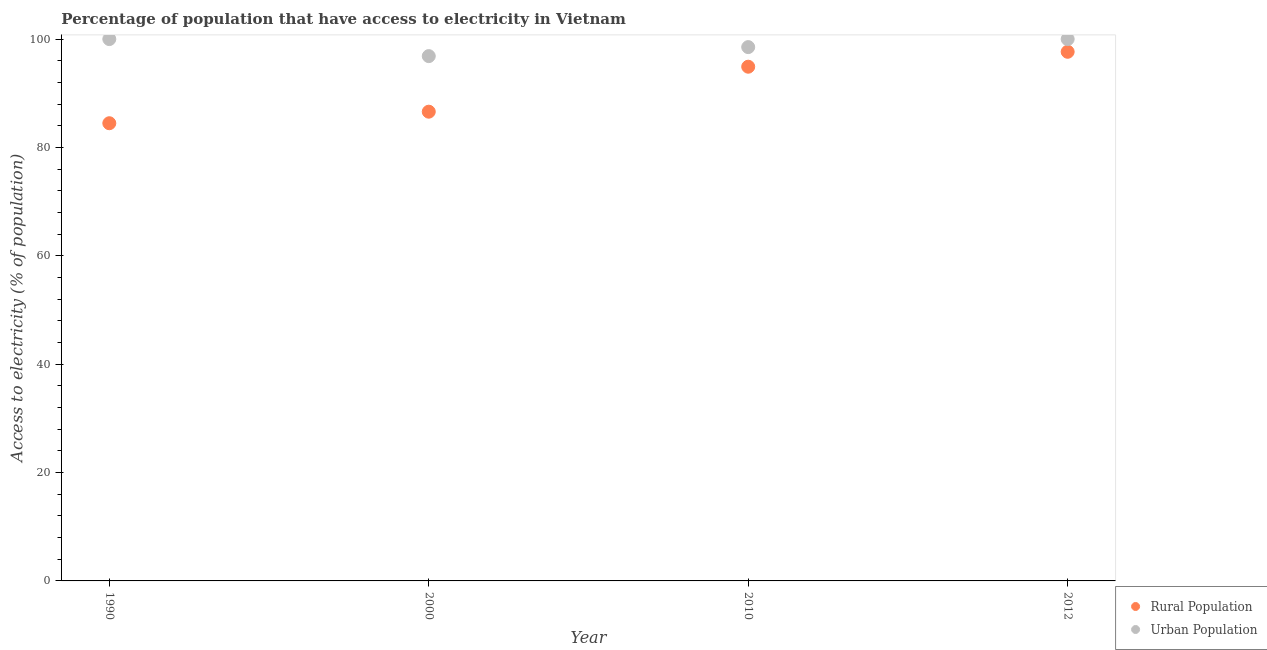How many different coloured dotlines are there?
Your answer should be very brief. 2. What is the percentage of urban population having access to electricity in 2000?
Keep it short and to the point. 96.86. Across all years, what is the maximum percentage of rural population having access to electricity?
Your response must be concise. 97.65. Across all years, what is the minimum percentage of urban population having access to electricity?
Provide a succinct answer. 96.86. In which year was the percentage of rural population having access to electricity maximum?
Provide a short and direct response. 2012. What is the total percentage of rural population having access to electricity in the graph?
Offer a very short reply. 363.62. What is the difference between the percentage of urban population having access to electricity in 2000 and that in 2010?
Your response must be concise. -1.66. What is the difference between the percentage of rural population having access to electricity in 2010 and the percentage of urban population having access to electricity in 2012?
Offer a terse response. -5.1. What is the average percentage of rural population having access to electricity per year?
Keep it short and to the point. 90.91. In the year 2012, what is the difference between the percentage of urban population having access to electricity and percentage of rural population having access to electricity?
Offer a very short reply. 2.35. In how many years, is the percentage of rural population having access to electricity greater than 84 %?
Your answer should be very brief. 4. What is the ratio of the percentage of rural population having access to electricity in 1990 to that in 2000?
Keep it short and to the point. 0.98. Is the percentage of rural population having access to electricity in 1990 less than that in 2000?
Make the answer very short. Yes. What is the difference between the highest and the second highest percentage of rural population having access to electricity?
Offer a terse response. 2.75. What is the difference between the highest and the lowest percentage of rural population having access to electricity?
Your answer should be compact. 13.18. Is the percentage of rural population having access to electricity strictly greater than the percentage of urban population having access to electricity over the years?
Ensure brevity in your answer.  No. Are the values on the major ticks of Y-axis written in scientific E-notation?
Your answer should be very brief. No. Where does the legend appear in the graph?
Keep it short and to the point. Bottom right. How many legend labels are there?
Provide a succinct answer. 2. How are the legend labels stacked?
Provide a short and direct response. Vertical. What is the title of the graph?
Keep it short and to the point. Percentage of population that have access to electricity in Vietnam. What is the label or title of the Y-axis?
Your answer should be compact. Access to electricity (% of population). What is the Access to electricity (% of population) of Rural Population in 1990?
Ensure brevity in your answer.  84.47. What is the Access to electricity (% of population) of Urban Population in 1990?
Ensure brevity in your answer.  100. What is the Access to electricity (% of population) in Rural Population in 2000?
Your response must be concise. 86.6. What is the Access to electricity (% of population) of Urban Population in 2000?
Offer a very short reply. 96.86. What is the Access to electricity (% of population) of Rural Population in 2010?
Your response must be concise. 94.9. What is the Access to electricity (% of population) in Urban Population in 2010?
Ensure brevity in your answer.  98.52. What is the Access to electricity (% of population) of Rural Population in 2012?
Give a very brief answer. 97.65. What is the Access to electricity (% of population) in Urban Population in 2012?
Offer a terse response. 100. Across all years, what is the maximum Access to electricity (% of population) of Rural Population?
Give a very brief answer. 97.65. Across all years, what is the maximum Access to electricity (% of population) in Urban Population?
Your answer should be compact. 100. Across all years, what is the minimum Access to electricity (% of population) of Rural Population?
Provide a short and direct response. 84.47. Across all years, what is the minimum Access to electricity (% of population) of Urban Population?
Your answer should be compact. 96.86. What is the total Access to electricity (% of population) in Rural Population in the graph?
Your answer should be compact. 363.62. What is the total Access to electricity (% of population) in Urban Population in the graph?
Your answer should be compact. 395.38. What is the difference between the Access to electricity (% of population) of Rural Population in 1990 and that in 2000?
Offer a very short reply. -2.13. What is the difference between the Access to electricity (% of population) of Urban Population in 1990 and that in 2000?
Make the answer very short. 3.14. What is the difference between the Access to electricity (% of population) of Rural Population in 1990 and that in 2010?
Provide a succinct answer. -10.43. What is the difference between the Access to electricity (% of population) of Urban Population in 1990 and that in 2010?
Offer a terse response. 1.48. What is the difference between the Access to electricity (% of population) in Rural Population in 1990 and that in 2012?
Keep it short and to the point. -13.18. What is the difference between the Access to electricity (% of population) in Urban Population in 1990 and that in 2012?
Offer a very short reply. 0. What is the difference between the Access to electricity (% of population) in Rural Population in 2000 and that in 2010?
Offer a very short reply. -8.3. What is the difference between the Access to electricity (% of population) in Urban Population in 2000 and that in 2010?
Your answer should be compact. -1.66. What is the difference between the Access to electricity (% of population) of Rural Population in 2000 and that in 2012?
Your response must be concise. -11.05. What is the difference between the Access to electricity (% of population) of Urban Population in 2000 and that in 2012?
Ensure brevity in your answer.  -3.14. What is the difference between the Access to electricity (% of population) of Rural Population in 2010 and that in 2012?
Provide a succinct answer. -2.75. What is the difference between the Access to electricity (% of population) of Urban Population in 2010 and that in 2012?
Your answer should be very brief. -1.48. What is the difference between the Access to electricity (% of population) of Rural Population in 1990 and the Access to electricity (% of population) of Urban Population in 2000?
Your response must be concise. -12.39. What is the difference between the Access to electricity (% of population) of Rural Population in 1990 and the Access to electricity (% of population) of Urban Population in 2010?
Your answer should be compact. -14.05. What is the difference between the Access to electricity (% of population) in Rural Population in 1990 and the Access to electricity (% of population) in Urban Population in 2012?
Keep it short and to the point. -15.53. What is the difference between the Access to electricity (% of population) of Rural Population in 2000 and the Access to electricity (% of population) of Urban Population in 2010?
Provide a succinct answer. -11.92. What is the difference between the Access to electricity (% of population) of Rural Population in 2010 and the Access to electricity (% of population) of Urban Population in 2012?
Ensure brevity in your answer.  -5.1. What is the average Access to electricity (% of population) in Rural Population per year?
Offer a very short reply. 90.91. What is the average Access to electricity (% of population) of Urban Population per year?
Your answer should be very brief. 98.84. In the year 1990, what is the difference between the Access to electricity (% of population) in Rural Population and Access to electricity (% of population) in Urban Population?
Your answer should be compact. -15.53. In the year 2000, what is the difference between the Access to electricity (% of population) in Rural Population and Access to electricity (% of population) in Urban Population?
Offer a very short reply. -10.26. In the year 2010, what is the difference between the Access to electricity (% of population) in Rural Population and Access to electricity (% of population) in Urban Population?
Give a very brief answer. -3.62. In the year 2012, what is the difference between the Access to electricity (% of population) of Rural Population and Access to electricity (% of population) of Urban Population?
Offer a very short reply. -2.35. What is the ratio of the Access to electricity (% of population) in Rural Population in 1990 to that in 2000?
Offer a terse response. 0.98. What is the ratio of the Access to electricity (% of population) in Urban Population in 1990 to that in 2000?
Keep it short and to the point. 1.03. What is the ratio of the Access to electricity (% of population) of Rural Population in 1990 to that in 2010?
Ensure brevity in your answer.  0.89. What is the ratio of the Access to electricity (% of population) of Urban Population in 1990 to that in 2010?
Give a very brief answer. 1.01. What is the ratio of the Access to electricity (% of population) of Rural Population in 1990 to that in 2012?
Give a very brief answer. 0.86. What is the ratio of the Access to electricity (% of population) of Urban Population in 1990 to that in 2012?
Give a very brief answer. 1. What is the ratio of the Access to electricity (% of population) of Rural Population in 2000 to that in 2010?
Ensure brevity in your answer.  0.91. What is the ratio of the Access to electricity (% of population) in Urban Population in 2000 to that in 2010?
Offer a very short reply. 0.98. What is the ratio of the Access to electricity (% of population) in Rural Population in 2000 to that in 2012?
Ensure brevity in your answer.  0.89. What is the ratio of the Access to electricity (% of population) of Urban Population in 2000 to that in 2012?
Give a very brief answer. 0.97. What is the ratio of the Access to electricity (% of population) in Rural Population in 2010 to that in 2012?
Make the answer very short. 0.97. What is the ratio of the Access to electricity (% of population) in Urban Population in 2010 to that in 2012?
Your answer should be very brief. 0.99. What is the difference between the highest and the second highest Access to electricity (% of population) in Rural Population?
Make the answer very short. 2.75. What is the difference between the highest and the lowest Access to electricity (% of population) in Rural Population?
Provide a succinct answer. 13.18. What is the difference between the highest and the lowest Access to electricity (% of population) in Urban Population?
Ensure brevity in your answer.  3.14. 